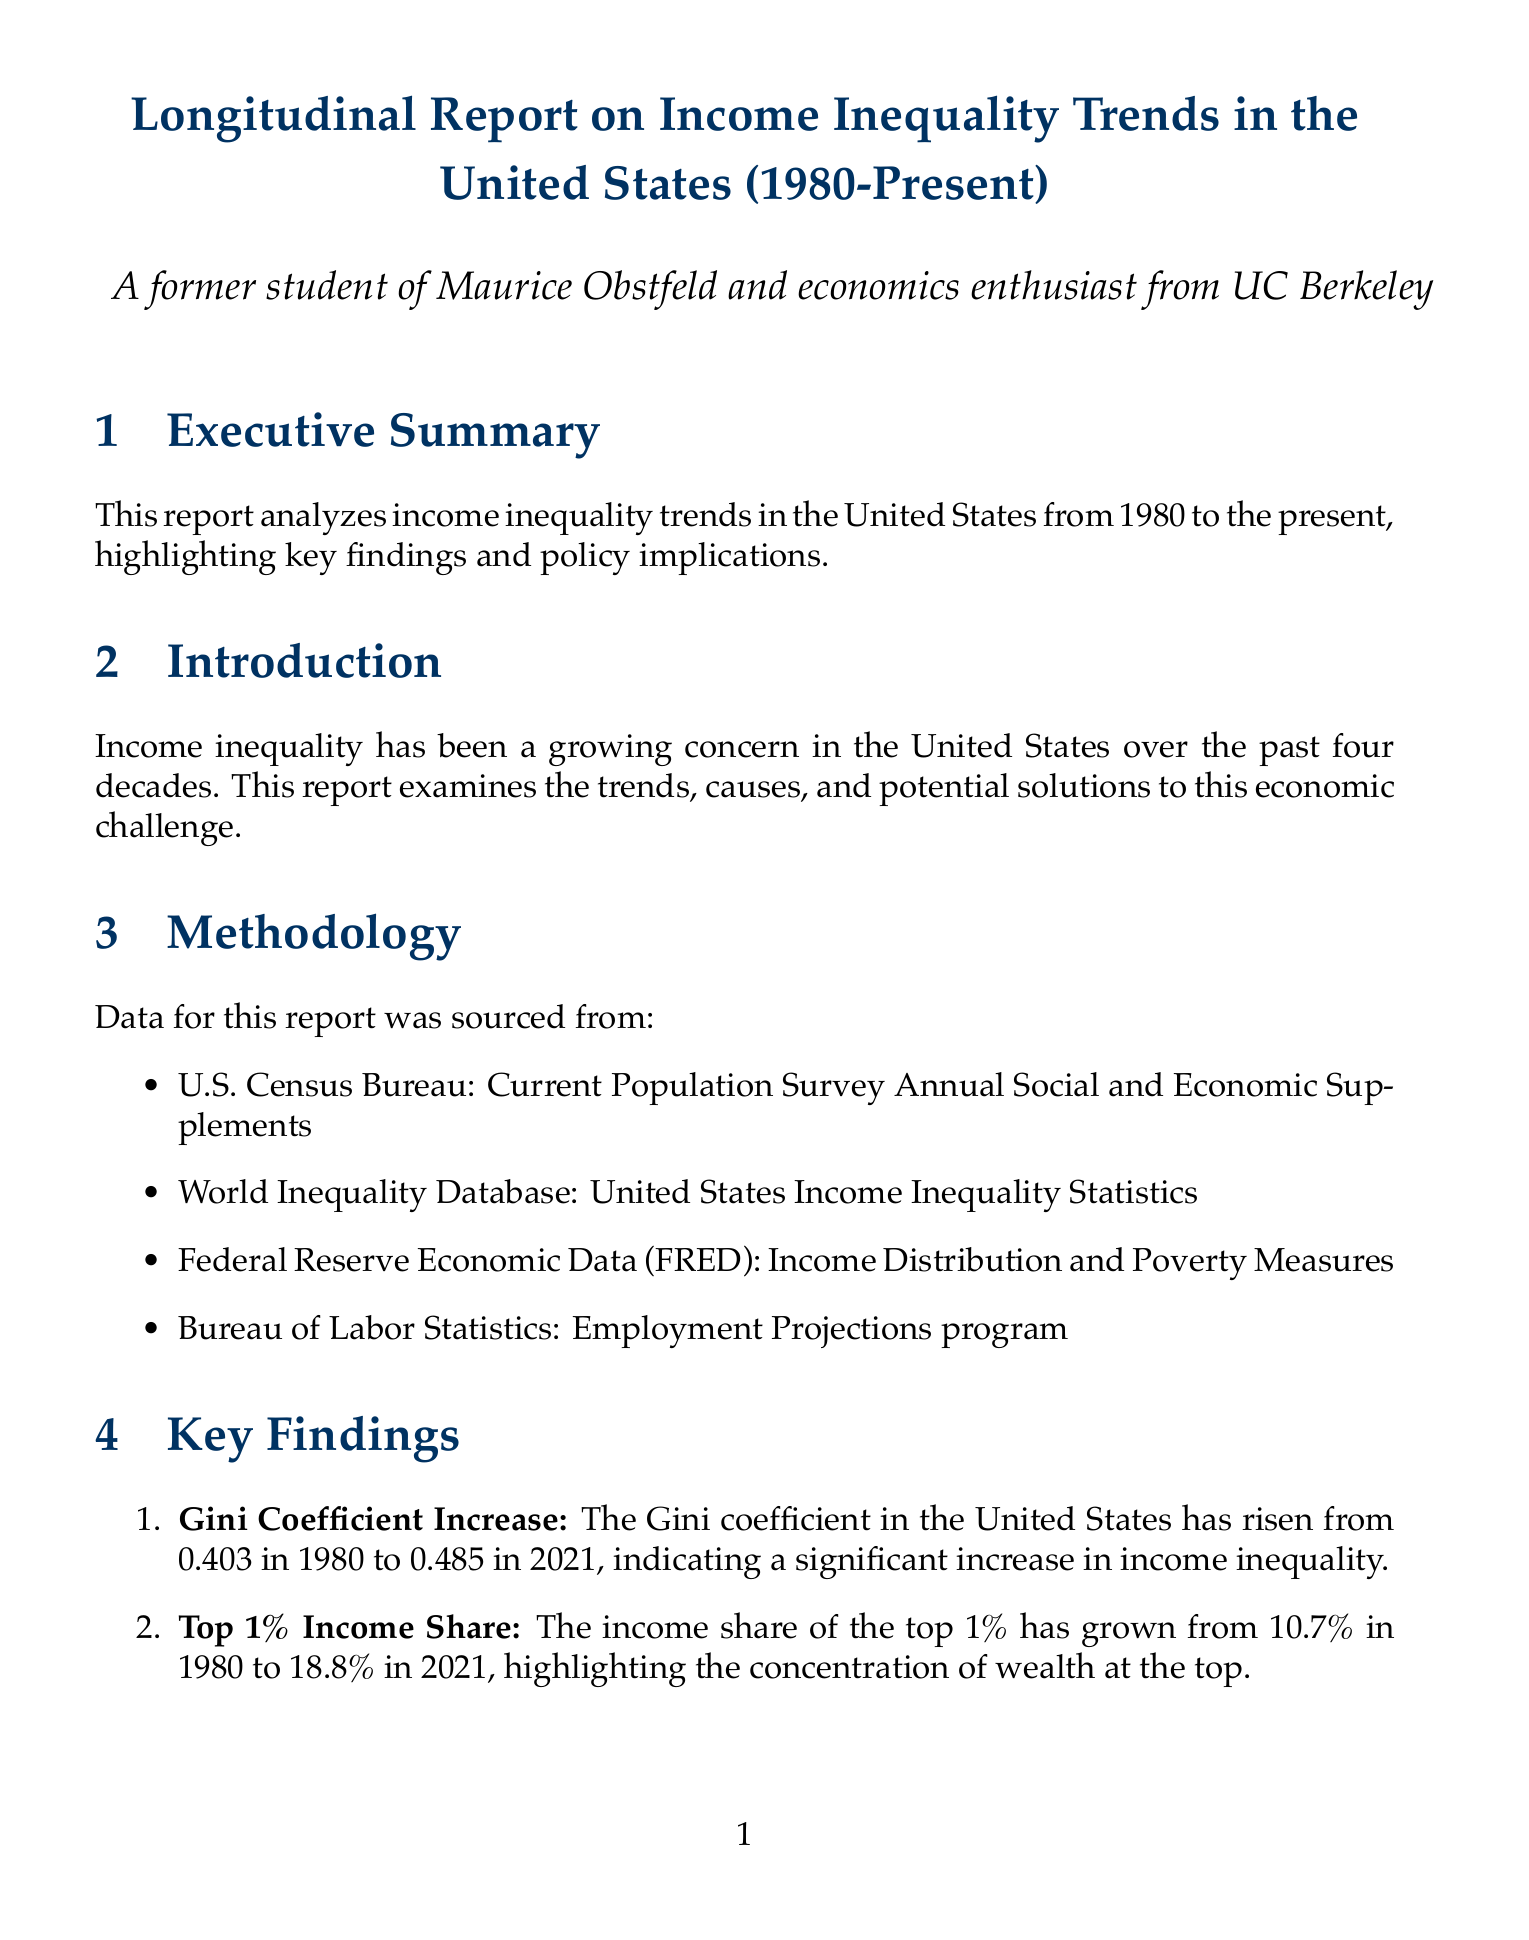What has the Gini coefficient increased to in 2021? The Gini coefficient has risen from 0.403 in 1980 to 0.485 in 2021, indicating a significant increase in income inequality.
Answer: 0.485 What was the income share of the top 1% in 1980? The income share of the top 1% has grown from 10.7% in 1980, highlighting the concentration of wealth at the top.
Answer: 10.7% What is the increase in real median household income from 1980 to 2021? Real median household income has grown by only 17.2% from 1980 to 2021, lagging far behind GDP growth and top earners' income growth.
Answer: 17.2% What theory explains increasing demand for skilled workers? This theory is proposed by economists like Daron Acemoglu, suggesting that technological advancements have increased demand for skilled workers, contributing to wage inequality.
Answer: Skill-Biased Technological Change Which policy is advocated to reduce the skills gap? Increasing funding for public education and skills training programs is recommended to reduce the skills gap.
Answer: Education Investment What is the Gini coefficient of France compared to the United States? France has maintained relatively stable income inequality levels since 1980, with a Gini coefficient around 0.3, significantly lower than the US.
Answer: 0.3 What is the primary concern addressed in this report? Income inequality has been a growing concern in the United States over the past four decades.
Answer: Income inequality Who is a UC Berkeley professor known for work on income inequality? Emmanuel Saez is known for his work on income inequality and optimal taxation.
Answer: Emmanuel Saez 